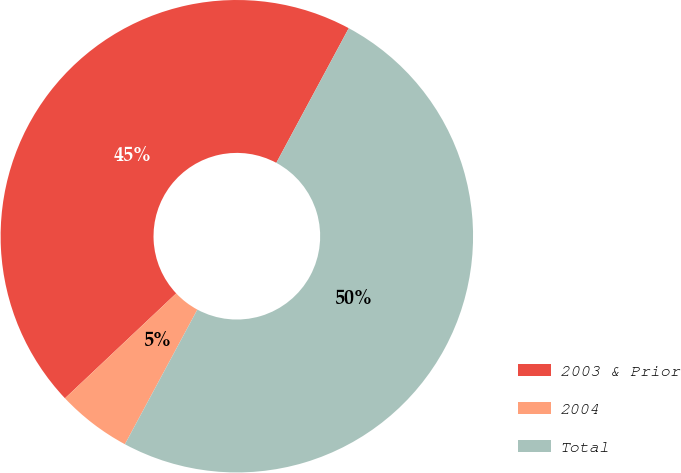Convert chart to OTSL. <chart><loc_0><loc_0><loc_500><loc_500><pie_chart><fcel>2003 & Prior<fcel>2004<fcel>Total<nl><fcel>44.89%<fcel>5.11%<fcel>50.0%<nl></chart> 